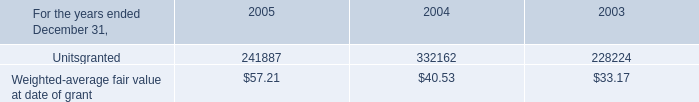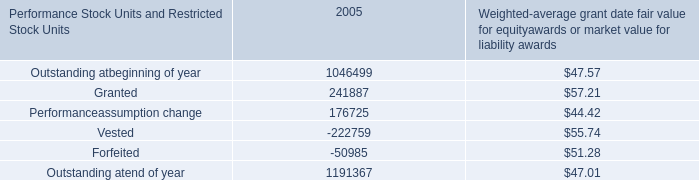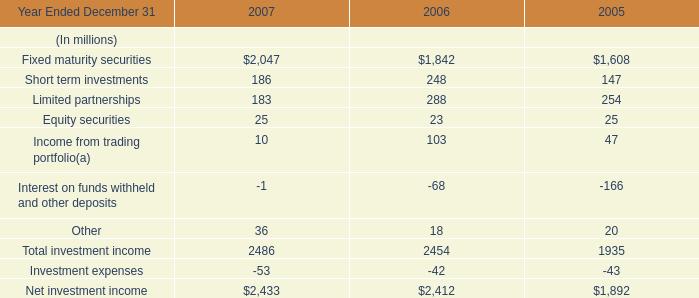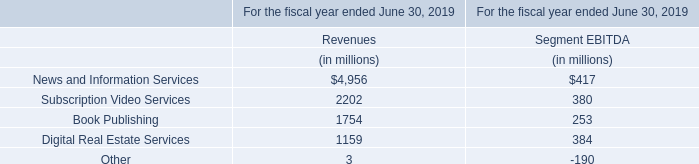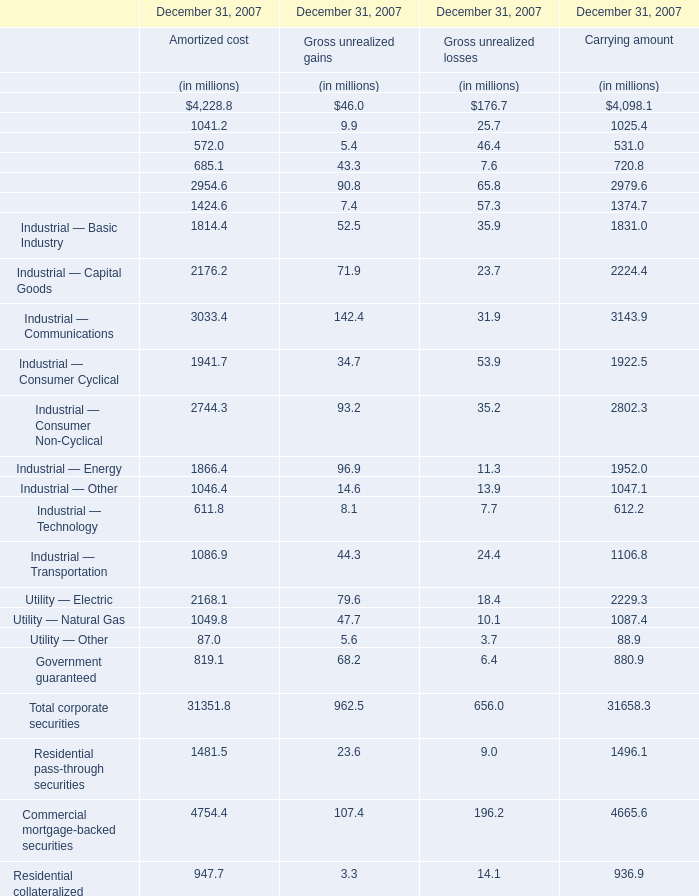What's the average of Net investment income of 2006, and Finance — Brokerage of December 31, 2007 Carrying amount ? 
Computations: ((2412.0 + 1025.4) / 2)
Answer: 1718.7. 